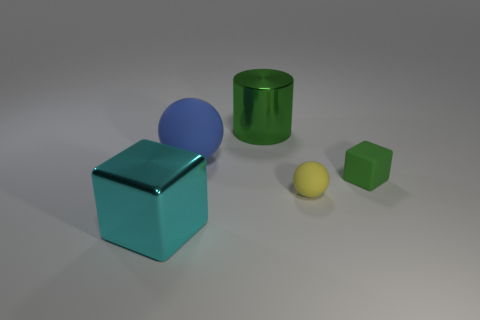Are there any other things that are the same shape as the green shiny object?
Provide a succinct answer. No. There is a blue object; are there any objects left of it?
Make the answer very short. Yes. How many metal objects are either tiny yellow spheres or large blue objects?
Ensure brevity in your answer.  0. There is a big blue rubber object; how many small objects are behind it?
Your answer should be very brief. 0. Is there a yellow sphere of the same size as the green matte object?
Your answer should be compact. Yes. Is there a rubber thing of the same color as the cylinder?
Offer a terse response. Yes. How many metal objects have the same color as the big ball?
Ensure brevity in your answer.  0. There is a matte block; is its color the same as the big metal object behind the tiny yellow rubber object?
Ensure brevity in your answer.  Yes. What number of objects are either small brown rubber things or matte things that are to the right of the yellow matte object?
Make the answer very short. 1. There is a block behind the big object to the left of the big blue matte thing; what size is it?
Offer a terse response. Small. 